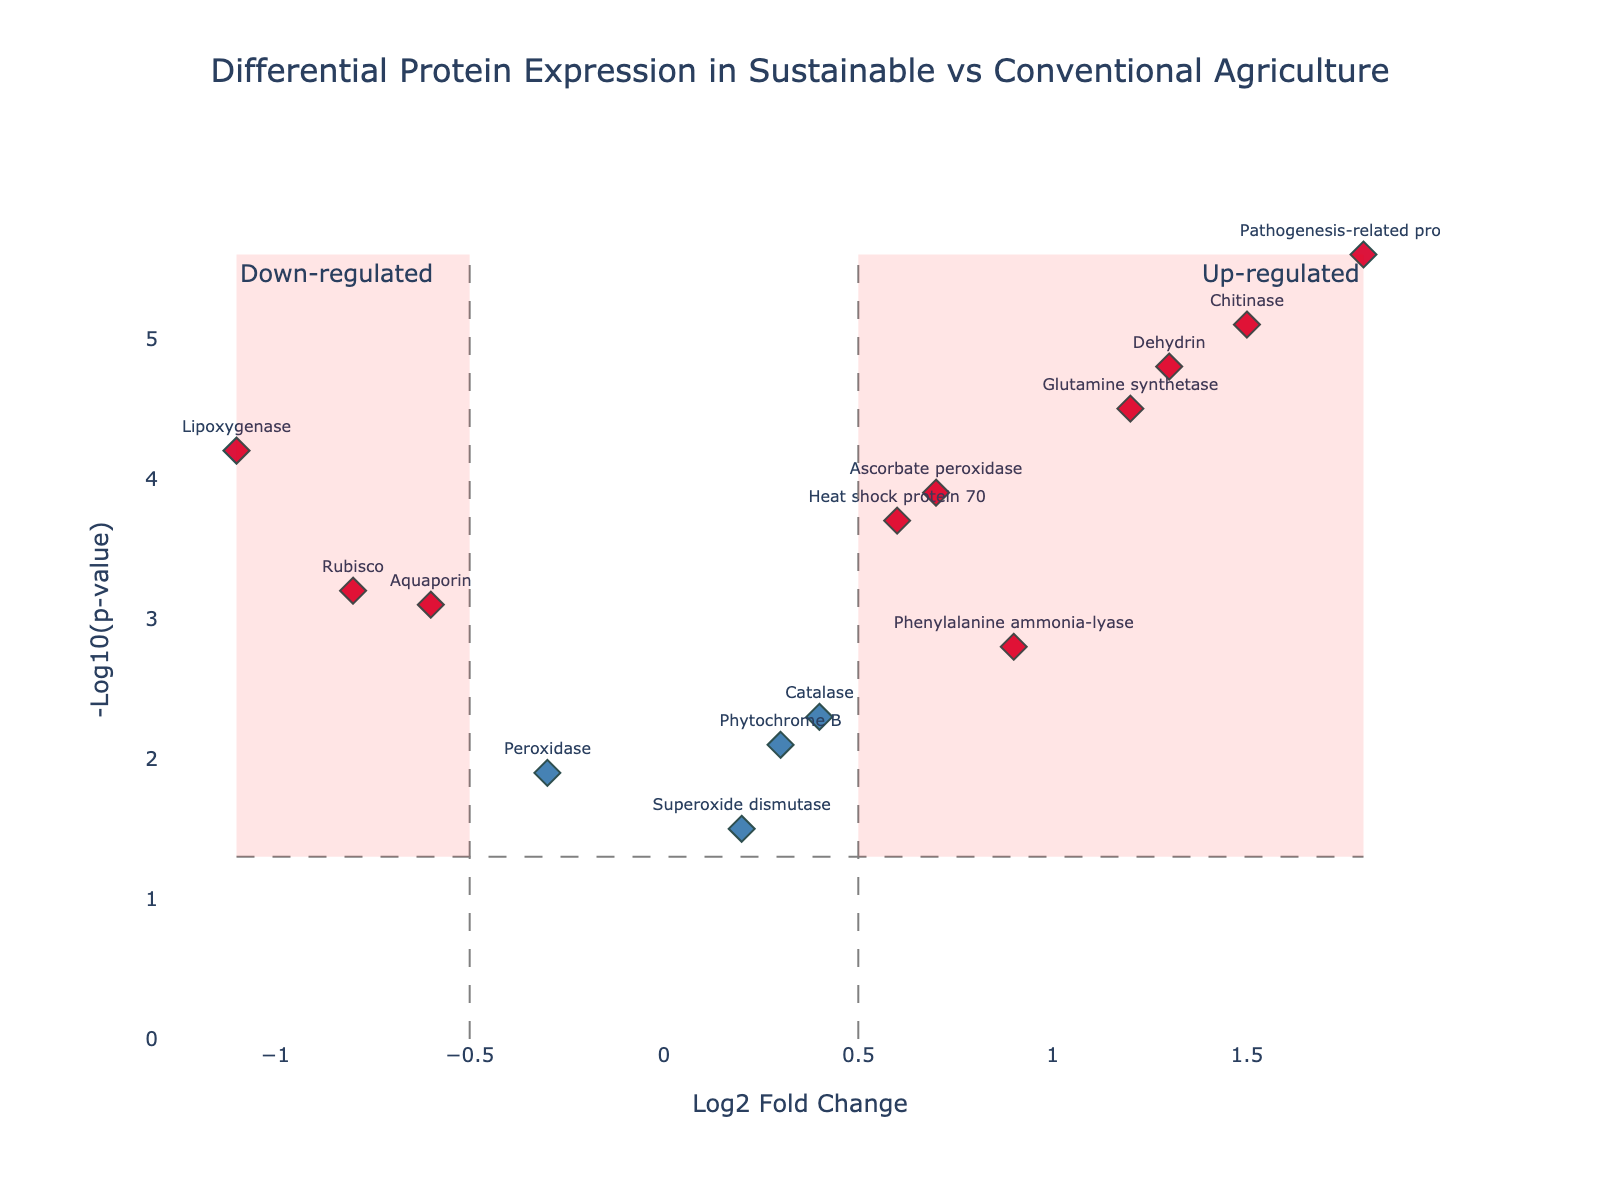What is the title of the figure? The title of the figure is found at the top and summarizes the content of the plot. In this case, it reads "Differential Protein Expression in Sustainable vs Conventional Agriculture".
Answer: Differential Protein Expression in Sustainable vs Conventional Agriculture How many proteins are shown in the plot? Each marker represents a protein. By counting the labels on the plot, we find there are 14 proteins presented.
Answer: 14 Which proteins are up-regulated in sustainable agriculture, based on the plot? Up-regulated proteins have positive Log2 Fold Change and are colored crimson if they are statistically significant. By examining positive Log2 Fold Change values and crimson markers, we identify the following up-regulated proteins: "Glutamine synthetase", "Phenylalanine ammonia-lyase", "Chitinase", "Heat shock protein 70", "Pathogenesis-related protein 1", "Ascorbate peroxidase", and "Dehydrin".
Answer: Glutamine synthetase, Phenylalanine ammonia-lyase, Chitinase, Heat shock protein 70, Pathogenesis-related protein 1, Ascorbate peroxidase, Dehydrin Which protein has the highest statistical significance in the plot? The statistical significance is denoted by the highest NegLog10PValue. The highest point on the y-axis represents this. Based on the data, this is "Pathogenesis-related protein 1" with a NegLog10PValue of 5.6.
Answer: Pathogenesis-related protein 1 Compare the significance of "Rubisco" and "Chitinase". Which one is more significant and by how much? The significance is measured by NegLog10PValue. "Rubisco" has a value of 3.2, and "Chitinase" has a value of 5.1. Subtracting these values gives the difference in significance: 5.1 - 3.2 = 1.9. Thus, "Chitinase" is more significant by 1.9 units.
Answer: Chitinase by 1.9 units What is the Log2 Fold Change value for "Lipoxygenase"? The Log2 Fold Change value for each protein is displayed along the x-axis. By locating "Lipoxygenase" on the plot, we see its Log2 Fold Change value is -1.1.
Answer: -1.1 Are there any proteins that are neither significantly up-regulated nor down-regulated? If so, which ones? Proteins that are neither significantly up-regulated nor down-regulated will have absolute Log2 Fold Change values ≤ 0.5 and NegLog10PValue ≤ 1.301 (since -log10(0.05) ≈ 1.301). By checking values, "Peroxidase", "Superoxide dismutase", and "Phytochrome B" fit these criteria.
Answer: Peroxidase, Superoxide dismutase, Phytochrome B Which proteins fall into the category of significantly down-regulated? Significantly down-regulated proteins have Log2 Fold Change values less than -0.5 and NegLog10PValue greater than 1.301, and they are colored crimson. Based on these criteria, the proteins are "Rubisco", "Lipoxygenase", and "Aquaporin".
Answer: Rubisco, Lipoxygenase, Aquaporin For the protein "Dehydrin", what are the values of Log2 Fold Change and NegLog10PValue? Finding "Dehydrin" on the plot, we see the text near the marker gives Log2 Fold Change as 1.3 and NegLog10PValue as 4.8.
Answer: Log2 Fold Change: 1.3, NegLog10PValue: 4.8 